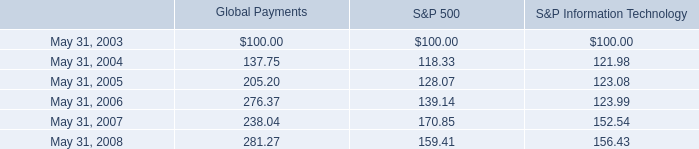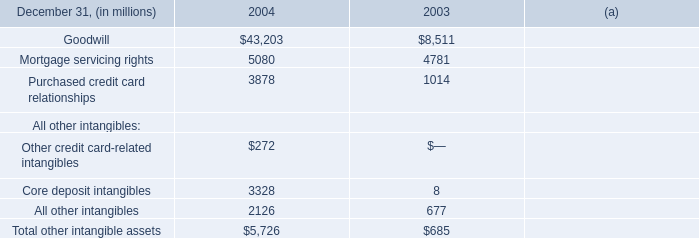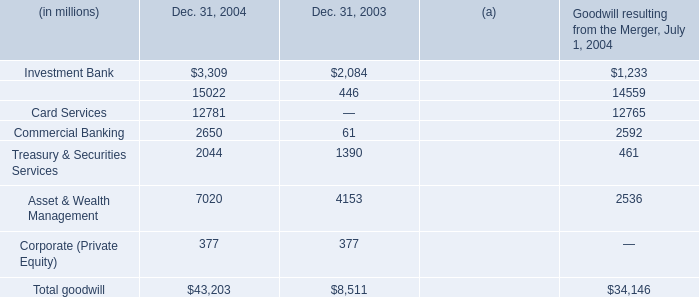Which element has the second largest number inDec. 31, 2004? 
Answer: Retail Financial Services. Which All other intangibles has the second largest number in 2004? 
Answer: All other intangibles. what is the highest total amount of Core deposit intangibles? (in million) 
Answer: 3328. 